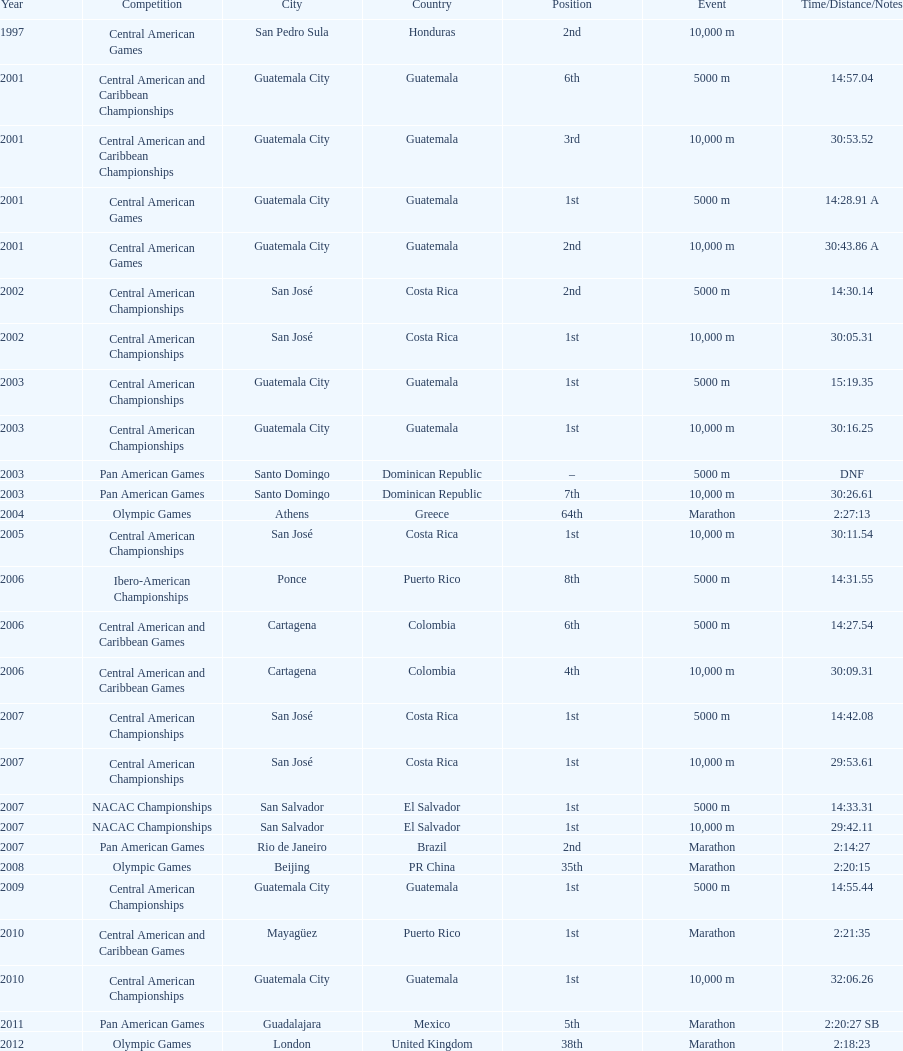The central american championships and what other competition occurred in 2010? Central American and Caribbean Games. 